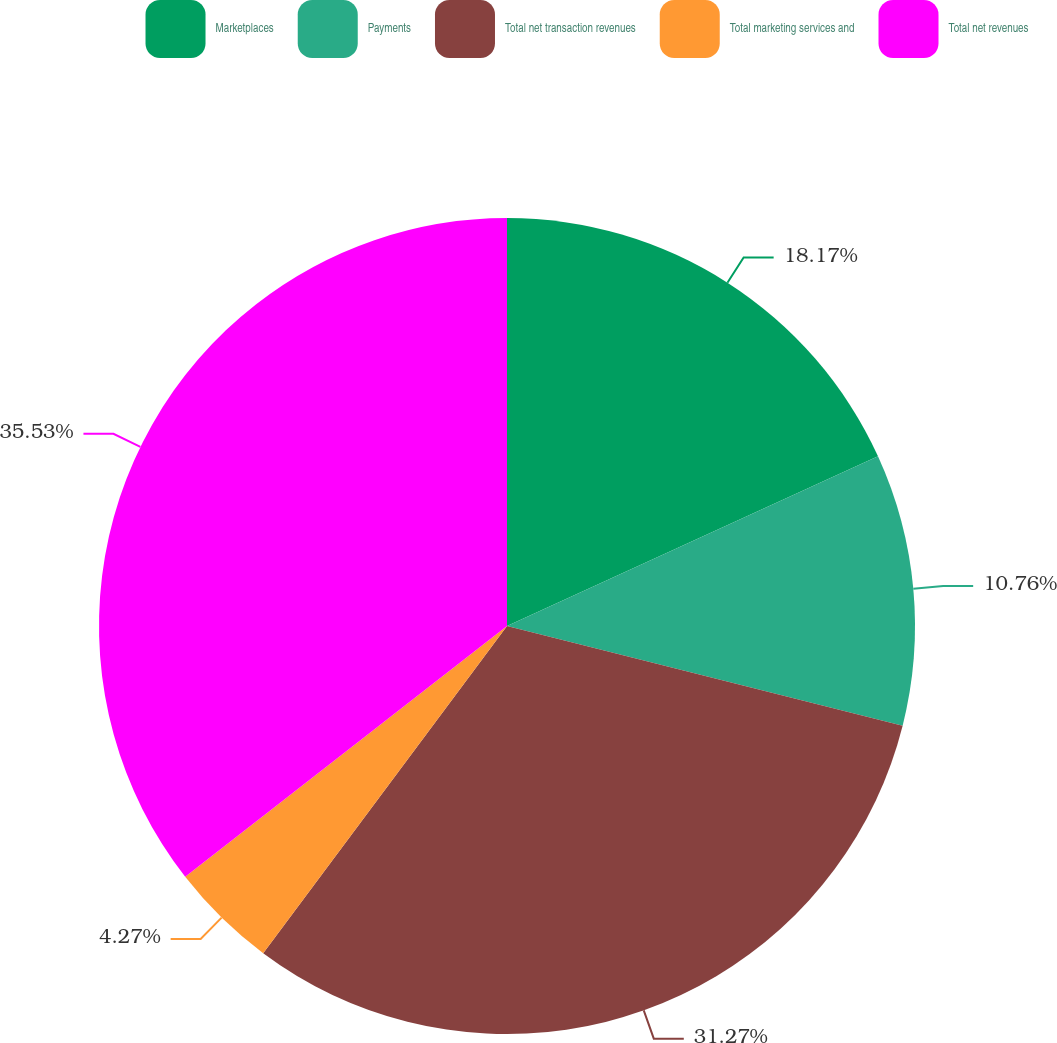Convert chart. <chart><loc_0><loc_0><loc_500><loc_500><pie_chart><fcel>Marketplaces<fcel>Payments<fcel>Total net transaction revenues<fcel>Total marketing services and<fcel>Total net revenues<nl><fcel>18.17%<fcel>10.76%<fcel>31.27%<fcel>4.27%<fcel>35.54%<nl></chart> 